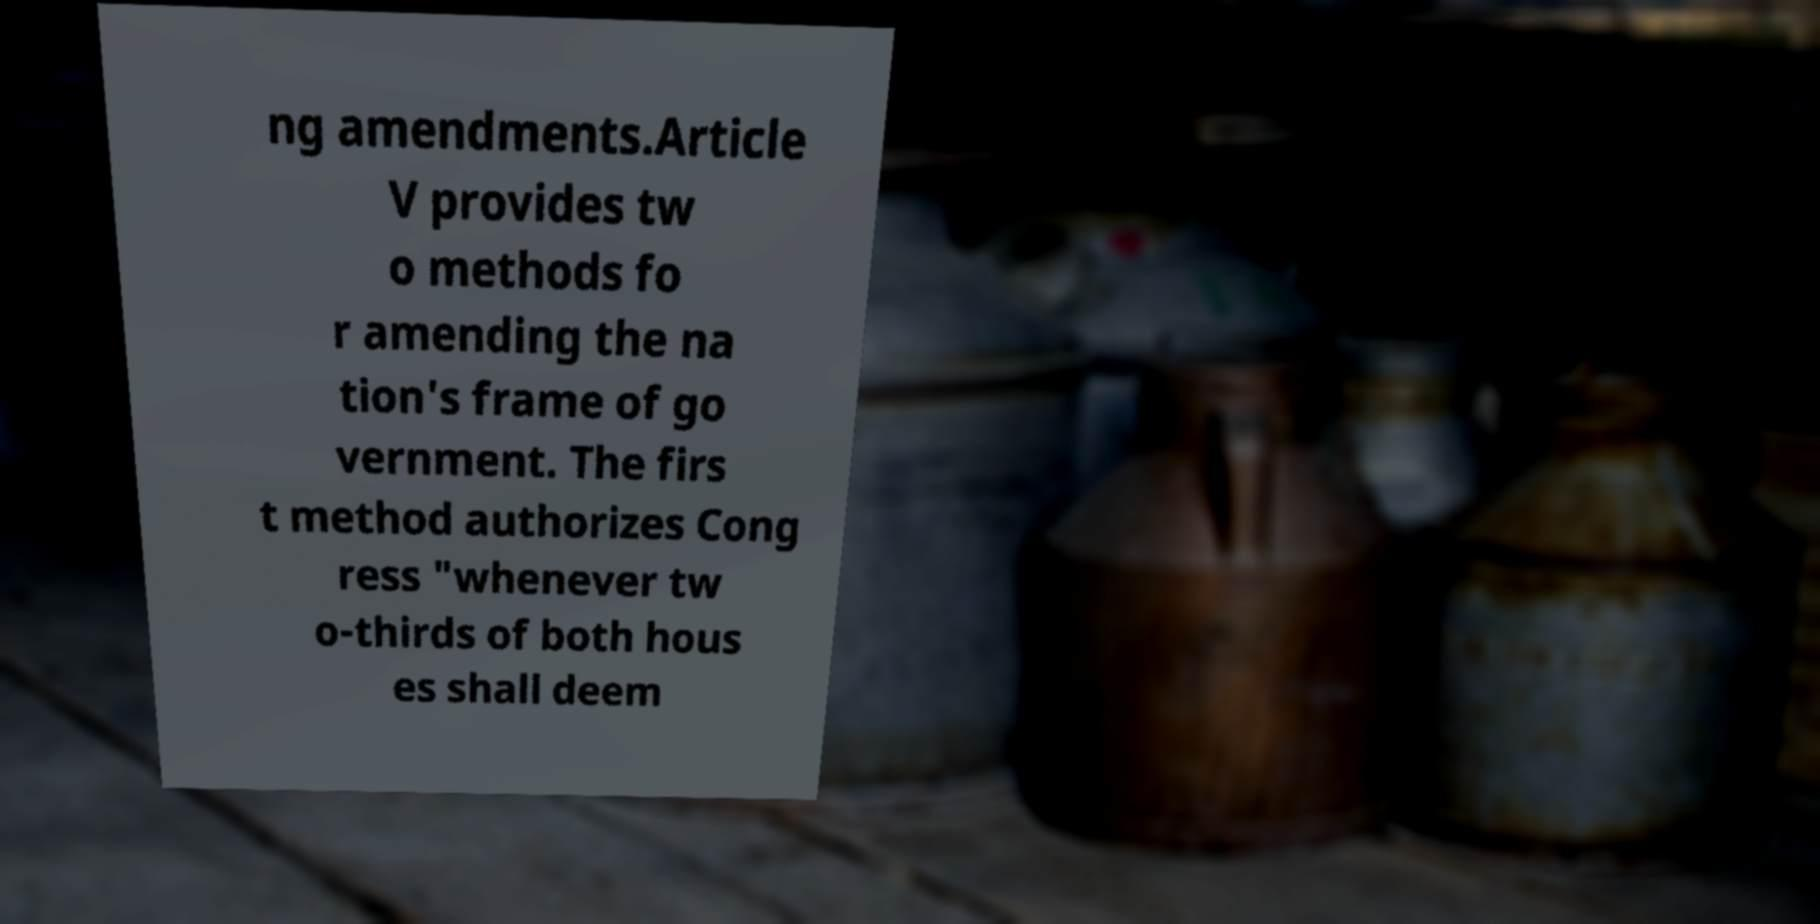I need the written content from this picture converted into text. Can you do that? ng amendments.Article V provides tw o methods fo r amending the na tion's frame of go vernment. The firs t method authorizes Cong ress "whenever tw o-thirds of both hous es shall deem 